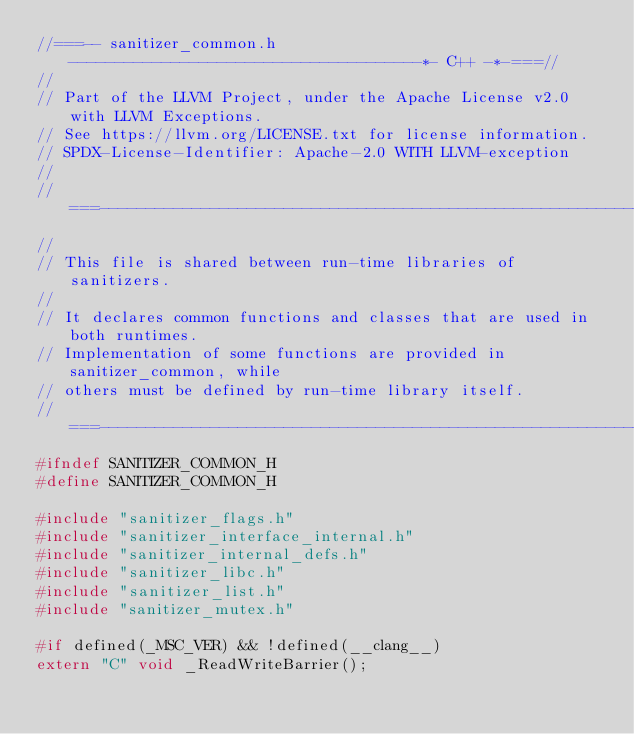Convert code to text. <code><loc_0><loc_0><loc_500><loc_500><_C_>//===-- sanitizer_common.h --------------------------------------*- C++ -*-===//
//
// Part of the LLVM Project, under the Apache License v2.0 with LLVM Exceptions.
// See https://llvm.org/LICENSE.txt for license information.
// SPDX-License-Identifier: Apache-2.0 WITH LLVM-exception
//
//===----------------------------------------------------------------------===//
//
// This file is shared between run-time libraries of sanitizers.
//
// It declares common functions and classes that are used in both runtimes.
// Implementation of some functions are provided in sanitizer_common, while
// others must be defined by run-time library itself.
//===----------------------------------------------------------------------===//
#ifndef SANITIZER_COMMON_H
#define SANITIZER_COMMON_H

#include "sanitizer_flags.h"
#include "sanitizer_interface_internal.h"
#include "sanitizer_internal_defs.h"
#include "sanitizer_libc.h"
#include "sanitizer_list.h"
#include "sanitizer_mutex.h"

#if defined(_MSC_VER) && !defined(__clang__)
extern "C" void _ReadWriteBarrier();</code> 